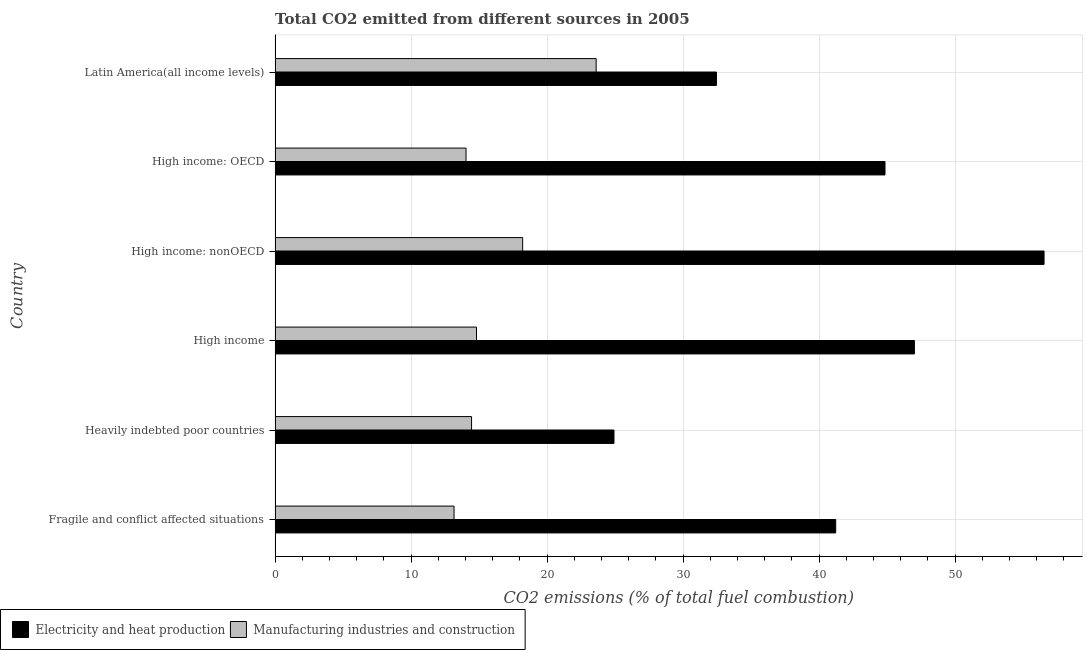Are the number of bars per tick equal to the number of legend labels?
Offer a terse response. Yes. How many bars are there on the 2nd tick from the top?
Provide a short and direct response. 2. What is the label of the 3rd group of bars from the top?
Offer a very short reply. High income: nonOECD. In how many cases, is the number of bars for a given country not equal to the number of legend labels?
Your answer should be compact. 0. What is the co2 emissions due to manufacturing industries in Fragile and conflict affected situations?
Make the answer very short. 13.16. Across all countries, what is the maximum co2 emissions due to manufacturing industries?
Your response must be concise. 23.61. Across all countries, what is the minimum co2 emissions due to manufacturing industries?
Keep it short and to the point. 13.16. In which country was the co2 emissions due to manufacturing industries maximum?
Make the answer very short. Latin America(all income levels). In which country was the co2 emissions due to electricity and heat production minimum?
Ensure brevity in your answer.  Heavily indebted poor countries. What is the total co2 emissions due to electricity and heat production in the graph?
Your answer should be very brief. 246.97. What is the difference between the co2 emissions due to manufacturing industries in High income and that in Latin America(all income levels)?
Provide a short and direct response. -8.8. What is the difference between the co2 emissions due to electricity and heat production in High income: OECD and the co2 emissions due to manufacturing industries in Latin America(all income levels)?
Give a very brief answer. 21.24. What is the average co2 emissions due to manufacturing industries per country?
Your response must be concise. 16.38. What is the difference between the co2 emissions due to manufacturing industries and co2 emissions due to electricity and heat production in Latin America(all income levels)?
Your response must be concise. -8.84. In how many countries, is the co2 emissions due to manufacturing industries greater than 56 %?
Keep it short and to the point. 0. What is the ratio of the co2 emissions due to electricity and heat production in Fragile and conflict affected situations to that in High income: OECD?
Offer a terse response. 0.92. Is the co2 emissions due to manufacturing industries in High income less than that in High income: OECD?
Provide a short and direct response. No. What is the difference between the highest and the second highest co2 emissions due to electricity and heat production?
Ensure brevity in your answer.  9.53. What is the difference between the highest and the lowest co2 emissions due to electricity and heat production?
Make the answer very short. 31.62. In how many countries, is the co2 emissions due to manufacturing industries greater than the average co2 emissions due to manufacturing industries taken over all countries?
Offer a very short reply. 2. What does the 1st bar from the top in Latin America(all income levels) represents?
Make the answer very short. Manufacturing industries and construction. What does the 2nd bar from the bottom in Fragile and conflict affected situations represents?
Keep it short and to the point. Manufacturing industries and construction. Are all the bars in the graph horizontal?
Provide a succinct answer. Yes. How many countries are there in the graph?
Your answer should be compact. 6. What is the difference between two consecutive major ticks on the X-axis?
Your answer should be very brief. 10. Does the graph contain any zero values?
Offer a very short reply. No. How many legend labels are there?
Provide a succinct answer. 2. What is the title of the graph?
Provide a succinct answer. Total CO2 emitted from different sources in 2005. What is the label or title of the X-axis?
Offer a terse response. CO2 emissions (% of total fuel combustion). What is the label or title of the Y-axis?
Keep it short and to the point. Country. What is the CO2 emissions (% of total fuel combustion) of Electricity and heat production in Fragile and conflict affected situations?
Your response must be concise. 41.22. What is the CO2 emissions (% of total fuel combustion) of Manufacturing industries and construction in Fragile and conflict affected situations?
Your answer should be very brief. 13.16. What is the CO2 emissions (% of total fuel combustion) of Electricity and heat production in Heavily indebted poor countries?
Provide a succinct answer. 24.92. What is the CO2 emissions (% of total fuel combustion) in Manufacturing industries and construction in Heavily indebted poor countries?
Ensure brevity in your answer.  14.45. What is the CO2 emissions (% of total fuel combustion) in Electricity and heat production in High income?
Make the answer very short. 47.01. What is the CO2 emissions (% of total fuel combustion) of Manufacturing industries and construction in High income?
Your response must be concise. 14.81. What is the CO2 emissions (% of total fuel combustion) of Electricity and heat production in High income: nonOECD?
Offer a very short reply. 56.54. What is the CO2 emissions (% of total fuel combustion) in Manufacturing industries and construction in High income: nonOECD?
Make the answer very short. 18.2. What is the CO2 emissions (% of total fuel combustion) of Electricity and heat production in High income: OECD?
Give a very brief answer. 44.84. What is the CO2 emissions (% of total fuel combustion) of Manufacturing industries and construction in High income: OECD?
Your answer should be compact. 14.04. What is the CO2 emissions (% of total fuel combustion) of Electricity and heat production in Latin America(all income levels)?
Provide a short and direct response. 32.45. What is the CO2 emissions (% of total fuel combustion) in Manufacturing industries and construction in Latin America(all income levels)?
Keep it short and to the point. 23.61. Across all countries, what is the maximum CO2 emissions (% of total fuel combustion) in Electricity and heat production?
Keep it short and to the point. 56.54. Across all countries, what is the maximum CO2 emissions (% of total fuel combustion) in Manufacturing industries and construction?
Your response must be concise. 23.61. Across all countries, what is the minimum CO2 emissions (% of total fuel combustion) in Electricity and heat production?
Keep it short and to the point. 24.92. Across all countries, what is the minimum CO2 emissions (% of total fuel combustion) of Manufacturing industries and construction?
Ensure brevity in your answer.  13.16. What is the total CO2 emissions (% of total fuel combustion) in Electricity and heat production in the graph?
Provide a succinct answer. 246.97. What is the total CO2 emissions (% of total fuel combustion) in Manufacturing industries and construction in the graph?
Offer a terse response. 98.26. What is the difference between the CO2 emissions (% of total fuel combustion) in Electricity and heat production in Fragile and conflict affected situations and that in Heavily indebted poor countries?
Keep it short and to the point. 16.3. What is the difference between the CO2 emissions (% of total fuel combustion) in Manufacturing industries and construction in Fragile and conflict affected situations and that in Heavily indebted poor countries?
Your answer should be compact. -1.29. What is the difference between the CO2 emissions (% of total fuel combustion) in Electricity and heat production in Fragile and conflict affected situations and that in High income?
Your answer should be very brief. -5.79. What is the difference between the CO2 emissions (% of total fuel combustion) in Manufacturing industries and construction in Fragile and conflict affected situations and that in High income?
Keep it short and to the point. -1.65. What is the difference between the CO2 emissions (% of total fuel combustion) of Electricity and heat production in Fragile and conflict affected situations and that in High income: nonOECD?
Your answer should be very brief. -15.32. What is the difference between the CO2 emissions (% of total fuel combustion) in Manufacturing industries and construction in Fragile and conflict affected situations and that in High income: nonOECD?
Keep it short and to the point. -5.05. What is the difference between the CO2 emissions (% of total fuel combustion) of Electricity and heat production in Fragile and conflict affected situations and that in High income: OECD?
Keep it short and to the point. -3.62. What is the difference between the CO2 emissions (% of total fuel combustion) in Manufacturing industries and construction in Fragile and conflict affected situations and that in High income: OECD?
Make the answer very short. -0.88. What is the difference between the CO2 emissions (% of total fuel combustion) of Electricity and heat production in Fragile and conflict affected situations and that in Latin America(all income levels)?
Provide a succinct answer. 8.77. What is the difference between the CO2 emissions (% of total fuel combustion) of Manufacturing industries and construction in Fragile and conflict affected situations and that in Latin America(all income levels)?
Keep it short and to the point. -10.45. What is the difference between the CO2 emissions (% of total fuel combustion) of Electricity and heat production in Heavily indebted poor countries and that in High income?
Ensure brevity in your answer.  -22.09. What is the difference between the CO2 emissions (% of total fuel combustion) in Manufacturing industries and construction in Heavily indebted poor countries and that in High income?
Your answer should be compact. -0.36. What is the difference between the CO2 emissions (% of total fuel combustion) in Electricity and heat production in Heavily indebted poor countries and that in High income: nonOECD?
Your response must be concise. -31.62. What is the difference between the CO2 emissions (% of total fuel combustion) in Manufacturing industries and construction in Heavily indebted poor countries and that in High income: nonOECD?
Offer a very short reply. -3.76. What is the difference between the CO2 emissions (% of total fuel combustion) in Electricity and heat production in Heavily indebted poor countries and that in High income: OECD?
Provide a short and direct response. -19.93. What is the difference between the CO2 emissions (% of total fuel combustion) of Manufacturing industries and construction in Heavily indebted poor countries and that in High income: OECD?
Your response must be concise. 0.41. What is the difference between the CO2 emissions (% of total fuel combustion) in Electricity and heat production in Heavily indebted poor countries and that in Latin America(all income levels)?
Ensure brevity in your answer.  -7.53. What is the difference between the CO2 emissions (% of total fuel combustion) of Manufacturing industries and construction in Heavily indebted poor countries and that in Latin America(all income levels)?
Keep it short and to the point. -9.16. What is the difference between the CO2 emissions (% of total fuel combustion) in Electricity and heat production in High income and that in High income: nonOECD?
Your response must be concise. -9.53. What is the difference between the CO2 emissions (% of total fuel combustion) in Manufacturing industries and construction in High income and that in High income: nonOECD?
Give a very brief answer. -3.39. What is the difference between the CO2 emissions (% of total fuel combustion) in Electricity and heat production in High income and that in High income: OECD?
Your answer should be very brief. 2.16. What is the difference between the CO2 emissions (% of total fuel combustion) in Manufacturing industries and construction in High income and that in High income: OECD?
Your answer should be very brief. 0.77. What is the difference between the CO2 emissions (% of total fuel combustion) in Electricity and heat production in High income and that in Latin America(all income levels)?
Make the answer very short. 14.56. What is the difference between the CO2 emissions (% of total fuel combustion) in Manufacturing industries and construction in High income and that in Latin America(all income levels)?
Provide a succinct answer. -8.8. What is the difference between the CO2 emissions (% of total fuel combustion) in Electricity and heat production in High income: nonOECD and that in High income: OECD?
Offer a very short reply. 11.69. What is the difference between the CO2 emissions (% of total fuel combustion) in Manufacturing industries and construction in High income: nonOECD and that in High income: OECD?
Make the answer very short. 4.16. What is the difference between the CO2 emissions (% of total fuel combustion) in Electricity and heat production in High income: nonOECD and that in Latin America(all income levels)?
Keep it short and to the point. 24.09. What is the difference between the CO2 emissions (% of total fuel combustion) in Manufacturing industries and construction in High income: nonOECD and that in Latin America(all income levels)?
Give a very brief answer. -5.4. What is the difference between the CO2 emissions (% of total fuel combustion) in Electricity and heat production in High income: OECD and that in Latin America(all income levels)?
Keep it short and to the point. 12.39. What is the difference between the CO2 emissions (% of total fuel combustion) of Manufacturing industries and construction in High income: OECD and that in Latin America(all income levels)?
Offer a very short reply. -9.57. What is the difference between the CO2 emissions (% of total fuel combustion) of Electricity and heat production in Fragile and conflict affected situations and the CO2 emissions (% of total fuel combustion) of Manufacturing industries and construction in Heavily indebted poor countries?
Offer a terse response. 26.77. What is the difference between the CO2 emissions (% of total fuel combustion) in Electricity and heat production in Fragile and conflict affected situations and the CO2 emissions (% of total fuel combustion) in Manufacturing industries and construction in High income?
Ensure brevity in your answer.  26.41. What is the difference between the CO2 emissions (% of total fuel combustion) of Electricity and heat production in Fragile and conflict affected situations and the CO2 emissions (% of total fuel combustion) of Manufacturing industries and construction in High income: nonOECD?
Give a very brief answer. 23.02. What is the difference between the CO2 emissions (% of total fuel combustion) in Electricity and heat production in Fragile and conflict affected situations and the CO2 emissions (% of total fuel combustion) in Manufacturing industries and construction in High income: OECD?
Your answer should be very brief. 27.18. What is the difference between the CO2 emissions (% of total fuel combustion) in Electricity and heat production in Fragile and conflict affected situations and the CO2 emissions (% of total fuel combustion) in Manufacturing industries and construction in Latin America(all income levels)?
Keep it short and to the point. 17.61. What is the difference between the CO2 emissions (% of total fuel combustion) of Electricity and heat production in Heavily indebted poor countries and the CO2 emissions (% of total fuel combustion) of Manufacturing industries and construction in High income?
Provide a short and direct response. 10.11. What is the difference between the CO2 emissions (% of total fuel combustion) of Electricity and heat production in Heavily indebted poor countries and the CO2 emissions (% of total fuel combustion) of Manufacturing industries and construction in High income: nonOECD?
Your answer should be compact. 6.71. What is the difference between the CO2 emissions (% of total fuel combustion) in Electricity and heat production in Heavily indebted poor countries and the CO2 emissions (% of total fuel combustion) in Manufacturing industries and construction in High income: OECD?
Give a very brief answer. 10.88. What is the difference between the CO2 emissions (% of total fuel combustion) of Electricity and heat production in Heavily indebted poor countries and the CO2 emissions (% of total fuel combustion) of Manufacturing industries and construction in Latin America(all income levels)?
Provide a succinct answer. 1.31. What is the difference between the CO2 emissions (% of total fuel combustion) in Electricity and heat production in High income and the CO2 emissions (% of total fuel combustion) in Manufacturing industries and construction in High income: nonOECD?
Keep it short and to the point. 28.8. What is the difference between the CO2 emissions (% of total fuel combustion) in Electricity and heat production in High income and the CO2 emissions (% of total fuel combustion) in Manufacturing industries and construction in High income: OECD?
Offer a terse response. 32.97. What is the difference between the CO2 emissions (% of total fuel combustion) of Electricity and heat production in High income and the CO2 emissions (% of total fuel combustion) of Manufacturing industries and construction in Latin America(all income levels)?
Ensure brevity in your answer.  23.4. What is the difference between the CO2 emissions (% of total fuel combustion) in Electricity and heat production in High income: nonOECD and the CO2 emissions (% of total fuel combustion) in Manufacturing industries and construction in High income: OECD?
Your answer should be compact. 42.5. What is the difference between the CO2 emissions (% of total fuel combustion) of Electricity and heat production in High income: nonOECD and the CO2 emissions (% of total fuel combustion) of Manufacturing industries and construction in Latin America(all income levels)?
Give a very brief answer. 32.93. What is the difference between the CO2 emissions (% of total fuel combustion) of Electricity and heat production in High income: OECD and the CO2 emissions (% of total fuel combustion) of Manufacturing industries and construction in Latin America(all income levels)?
Ensure brevity in your answer.  21.24. What is the average CO2 emissions (% of total fuel combustion) in Electricity and heat production per country?
Make the answer very short. 41.16. What is the average CO2 emissions (% of total fuel combustion) in Manufacturing industries and construction per country?
Your response must be concise. 16.38. What is the difference between the CO2 emissions (% of total fuel combustion) in Electricity and heat production and CO2 emissions (% of total fuel combustion) in Manufacturing industries and construction in Fragile and conflict affected situations?
Ensure brevity in your answer.  28.06. What is the difference between the CO2 emissions (% of total fuel combustion) of Electricity and heat production and CO2 emissions (% of total fuel combustion) of Manufacturing industries and construction in Heavily indebted poor countries?
Offer a terse response. 10.47. What is the difference between the CO2 emissions (% of total fuel combustion) in Electricity and heat production and CO2 emissions (% of total fuel combustion) in Manufacturing industries and construction in High income?
Your answer should be very brief. 32.2. What is the difference between the CO2 emissions (% of total fuel combustion) in Electricity and heat production and CO2 emissions (% of total fuel combustion) in Manufacturing industries and construction in High income: nonOECD?
Give a very brief answer. 38.33. What is the difference between the CO2 emissions (% of total fuel combustion) in Electricity and heat production and CO2 emissions (% of total fuel combustion) in Manufacturing industries and construction in High income: OECD?
Keep it short and to the point. 30.8. What is the difference between the CO2 emissions (% of total fuel combustion) in Electricity and heat production and CO2 emissions (% of total fuel combustion) in Manufacturing industries and construction in Latin America(all income levels)?
Your answer should be compact. 8.84. What is the ratio of the CO2 emissions (% of total fuel combustion) in Electricity and heat production in Fragile and conflict affected situations to that in Heavily indebted poor countries?
Your response must be concise. 1.65. What is the ratio of the CO2 emissions (% of total fuel combustion) of Manufacturing industries and construction in Fragile and conflict affected situations to that in Heavily indebted poor countries?
Your answer should be very brief. 0.91. What is the ratio of the CO2 emissions (% of total fuel combustion) in Electricity and heat production in Fragile and conflict affected situations to that in High income?
Your answer should be very brief. 0.88. What is the ratio of the CO2 emissions (% of total fuel combustion) in Manufacturing industries and construction in Fragile and conflict affected situations to that in High income?
Provide a succinct answer. 0.89. What is the ratio of the CO2 emissions (% of total fuel combustion) in Electricity and heat production in Fragile and conflict affected situations to that in High income: nonOECD?
Make the answer very short. 0.73. What is the ratio of the CO2 emissions (% of total fuel combustion) in Manufacturing industries and construction in Fragile and conflict affected situations to that in High income: nonOECD?
Make the answer very short. 0.72. What is the ratio of the CO2 emissions (% of total fuel combustion) in Electricity and heat production in Fragile and conflict affected situations to that in High income: OECD?
Make the answer very short. 0.92. What is the ratio of the CO2 emissions (% of total fuel combustion) in Manufacturing industries and construction in Fragile and conflict affected situations to that in High income: OECD?
Give a very brief answer. 0.94. What is the ratio of the CO2 emissions (% of total fuel combustion) in Electricity and heat production in Fragile and conflict affected situations to that in Latin America(all income levels)?
Your answer should be compact. 1.27. What is the ratio of the CO2 emissions (% of total fuel combustion) of Manufacturing industries and construction in Fragile and conflict affected situations to that in Latin America(all income levels)?
Your response must be concise. 0.56. What is the ratio of the CO2 emissions (% of total fuel combustion) of Electricity and heat production in Heavily indebted poor countries to that in High income?
Keep it short and to the point. 0.53. What is the ratio of the CO2 emissions (% of total fuel combustion) of Manufacturing industries and construction in Heavily indebted poor countries to that in High income?
Ensure brevity in your answer.  0.98. What is the ratio of the CO2 emissions (% of total fuel combustion) of Electricity and heat production in Heavily indebted poor countries to that in High income: nonOECD?
Give a very brief answer. 0.44. What is the ratio of the CO2 emissions (% of total fuel combustion) in Manufacturing industries and construction in Heavily indebted poor countries to that in High income: nonOECD?
Your response must be concise. 0.79. What is the ratio of the CO2 emissions (% of total fuel combustion) in Electricity and heat production in Heavily indebted poor countries to that in High income: OECD?
Provide a short and direct response. 0.56. What is the ratio of the CO2 emissions (% of total fuel combustion) of Manufacturing industries and construction in Heavily indebted poor countries to that in High income: OECD?
Offer a terse response. 1.03. What is the ratio of the CO2 emissions (% of total fuel combustion) in Electricity and heat production in Heavily indebted poor countries to that in Latin America(all income levels)?
Provide a short and direct response. 0.77. What is the ratio of the CO2 emissions (% of total fuel combustion) of Manufacturing industries and construction in Heavily indebted poor countries to that in Latin America(all income levels)?
Provide a succinct answer. 0.61. What is the ratio of the CO2 emissions (% of total fuel combustion) of Electricity and heat production in High income to that in High income: nonOECD?
Your response must be concise. 0.83. What is the ratio of the CO2 emissions (% of total fuel combustion) of Manufacturing industries and construction in High income to that in High income: nonOECD?
Offer a terse response. 0.81. What is the ratio of the CO2 emissions (% of total fuel combustion) of Electricity and heat production in High income to that in High income: OECD?
Your answer should be very brief. 1.05. What is the ratio of the CO2 emissions (% of total fuel combustion) of Manufacturing industries and construction in High income to that in High income: OECD?
Your answer should be compact. 1.05. What is the ratio of the CO2 emissions (% of total fuel combustion) of Electricity and heat production in High income to that in Latin America(all income levels)?
Provide a succinct answer. 1.45. What is the ratio of the CO2 emissions (% of total fuel combustion) of Manufacturing industries and construction in High income to that in Latin America(all income levels)?
Ensure brevity in your answer.  0.63. What is the ratio of the CO2 emissions (% of total fuel combustion) in Electricity and heat production in High income: nonOECD to that in High income: OECD?
Give a very brief answer. 1.26. What is the ratio of the CO2 emissions (% of total fuel combustion) of Manufacturing industries and construction in High income: nonOECD to that in High income: OECD?
Your response must be concise. 1.3. What is the ratio of the CO2 emissions (% of total fuel combustion) in Electricity and heat production in High income: nonOECD to that in Latin America(all income levels)?
Your answer should be compact. 1.74. What is the ratio of the CO2 emissions (% of total fuel combustion) in Manufacturing industries and construction in High income: nonOECD to that in Latin America(all income levels)?
Give a very brief answer. 0.77. What is the ratio of the CO2 emissions (% of total fuel combustion) in Electricity and heat production in High income: OECD to that in Latin America(all income levels)?
Offer a terse response. 1.38. What is the ratio of the CO2 emissions (% of total fuel combustion) in Manufacturing industries and construction in High income: OECD to that in Latin America(all income levels)?
Ensure brevity in your answer.  0.59. What is the difference between the highest and the second highest CO2 emissions (% of total fuel combustion) in Electricity and heat production?
Keep it short and to the point. 9.53. What is the difference between the highest and the second highest CO2 emissions (% of total fuel combustion) of Manufacturing industries and construction?
Your answer should be very brief. 5.4. What is the difference between the highest and the lowest CO2 emissions (% of total fuel combustion) in Electricity and heat production?
Offer a very short reply. 31.62. What is the difference between the highest and the lowest CO2 emissions (% of total fuel combustion) in Manufacturing industries and construction?
Ensure brevity in your answer.  10.45. 